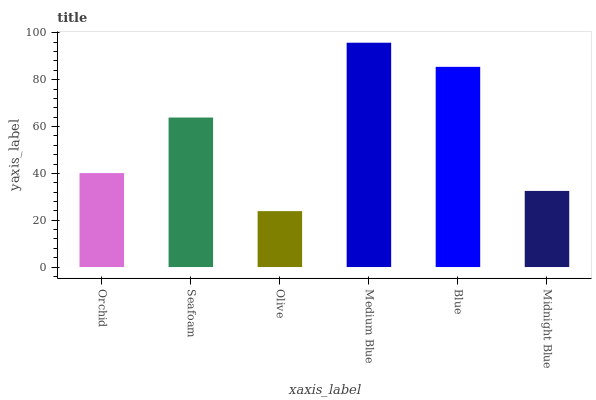Is Seafoam the minimum?
Answer yes or no. No. Is Seafoam the maximum?
Answer yes or no. No. Is Seafoam greater than Orchid?
Answer yes or no. Yes. Is Orchid less than Seafoam?
Answer yes or no. Yes. Is Orchid greater than Seafoam?
Answer yes or no. No. Is Seafoam less than Orchid?
Answer yes or no. No. Is Seafoam the high median?
Answer yes or no. Yes. Is Orchid the low median?
Answer yes or no. Yes. Is Blue the high median?
Answer yes or no. No. Is Midnight Blue the low median?
Answer yes or no. No. 